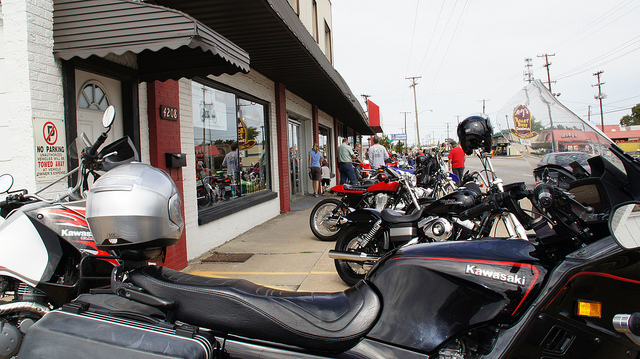Please transcribe the text information in this image. Kawasaki Kawas PARKING NO P 4208 